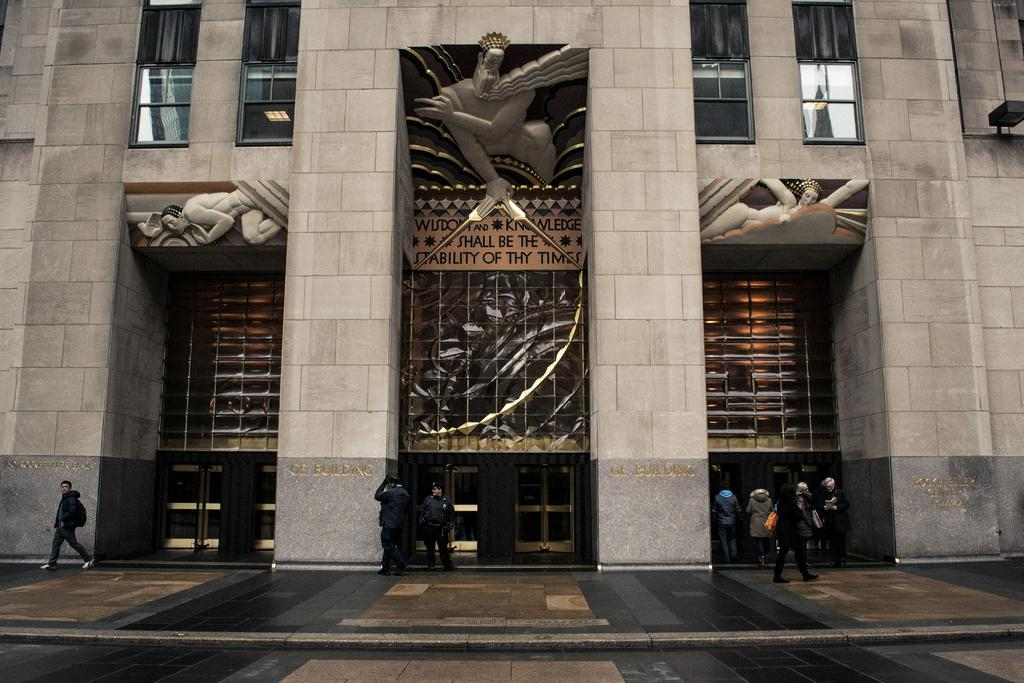What type of structure is present in the image? There is a building in the image. Can you describe the people in the image? There are people standing on the ground in the image. What architectural feature can be seen in the image? There are pillars visible in the image. What type of material is used for the window in the image? There is a glass window in the image. What type of plants can be seen growing on the icicle in the image? There is no icicle present in the image, and therefore no plants growing on it. 